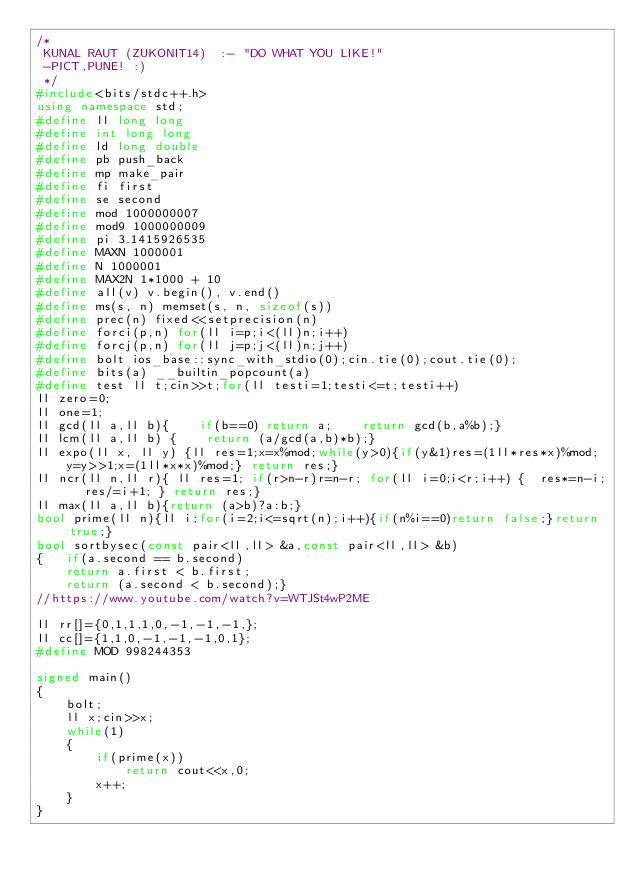<code> <loc_0><loc_0><loc_500><loc_500><_C++_>/*
 KUNAL RAUT (ZUKONIT14)  :- "DO WHAT YOU LIKE!"
 -PICT,PUNE! :)
 */
#include<bits/stdc++.h>
using namespace std;
#define ll long long
#define int long long
#define ld long double
#define pb push_back
#define mp make_pair
#define fi first
#define se second
#define mod 1000000007
#define mod9 1000000009
#define pi 3.1415926535
#define MAXN 1000001
#define N 1000001
#define MAX2N 1*1000 + 10
#define all(v) v.begin(), v.end()
#define ms(s, n) memset(s, n, sizeof(s))
#define prec(n) fixed<<setprecision(n)
#define forci(p,n) for(ll i=p;i<(ll)n;i++)
#define forcj(p,n) for(ll j=p;j<(ll)n;j++)
#define bolt ios_base::sync_with_stdio(0);cin.tie(0);cout.tie(0);
#define bits(a) __builtin_popcount(a)
#define test ll t;cin>>t;for(ll testi=1;testi<=t;testi++)
ll zero=0;
ll one=1;
ll gcd(ll a,ll b){    if(b==0) return a;    return gcd(b,a%b);}
ll lcm(ll a,ll b) {    return (a/gcd(a,b)*b);}
ll expo(ll x, ll y) {ll res=1;x=x%mod;while(y>0){if(y&1)res=(1ll*res*x)%mod;
    y=y>>1;x=(1ll*x*x)%mod;} return res;}
ll ncr(ll n,ll r){ ll res=1; if(r>n-r)r=n-r; for(ll i=0;i<r;i++) {  res*=n-i;  res/=i+1; } return res;}
ll max(ll a,ll b){return (a>b)?a:b;}
bool prime(ll n){ll i;for(i=2;i<=sqrt(n);i++){if(n%i==0)return false;}return true;}
bool sortbysec(const pair<ll,ll> &a,const pair<ll,ll> &b)
{   if(a.second == b.second)
    return a.first < b.first;
    return (a.second < b.second);}
//https://www.youtube.com/watch?v=WTJSt4wP2ME

ll rr[]={0,1,1,1,0,-1,-1,-1,};
ll cc[]={1,1,0,-1,-1,-1,0,1};
#define MOD 998244353

signed main()
{
    bolt;
    ll x;cin>>x;
    while(1)
    {
        if(prime(x))
            return cout<<x,0;
        x++;
    }
}

</code> 